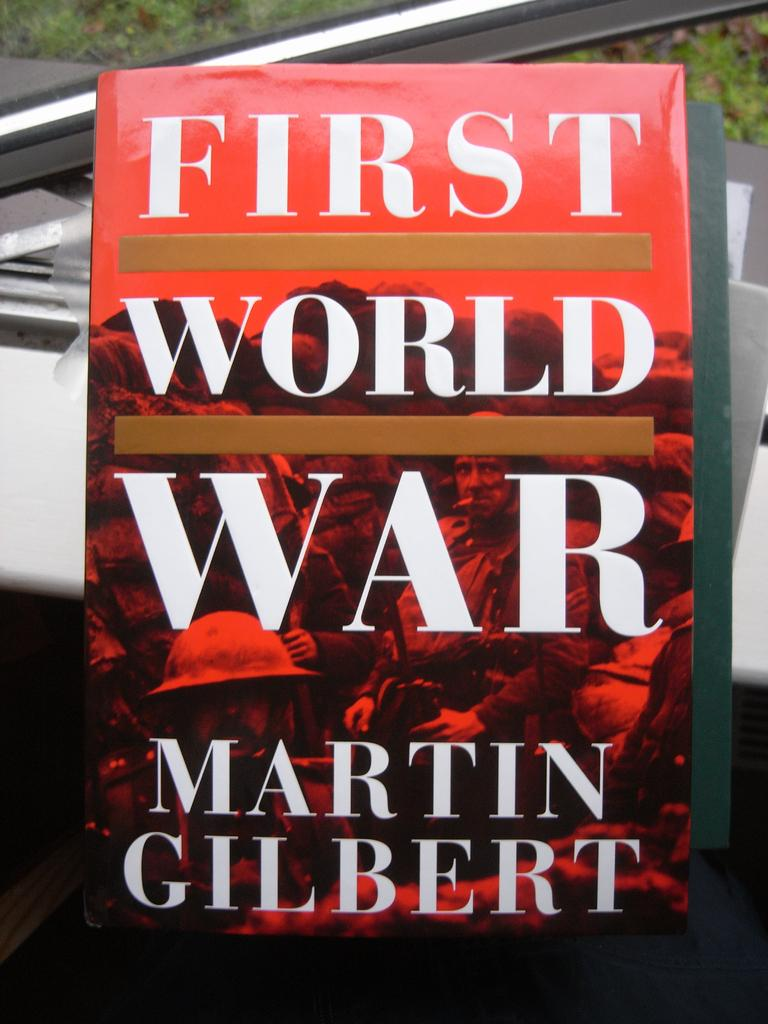What is the main object in the image? There is a book in the image. What can be seen in the background of the image? There is grass visible in the background of the image. Can you describe any other objects in the background? There are some unspecified objects in the background of the image. What scent can be detected coming from the book in the image? There is no information about the scent of the book in the image, so it cannot be determined. 